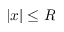<formula> <loc_0><loc_0><loc_500><loc_500>| x | \leq R</formula> 